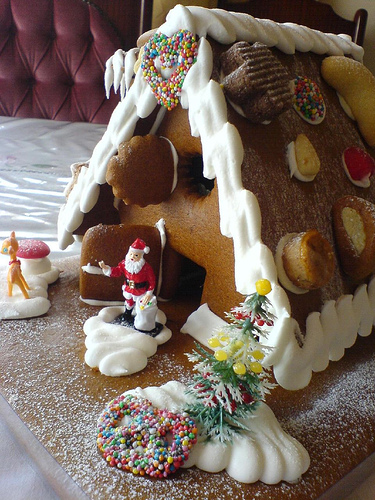<image>
Is there a santa to the left of the tree? Yes. From this viewpoint, the santa is positioned to the left side relative to the tree. 